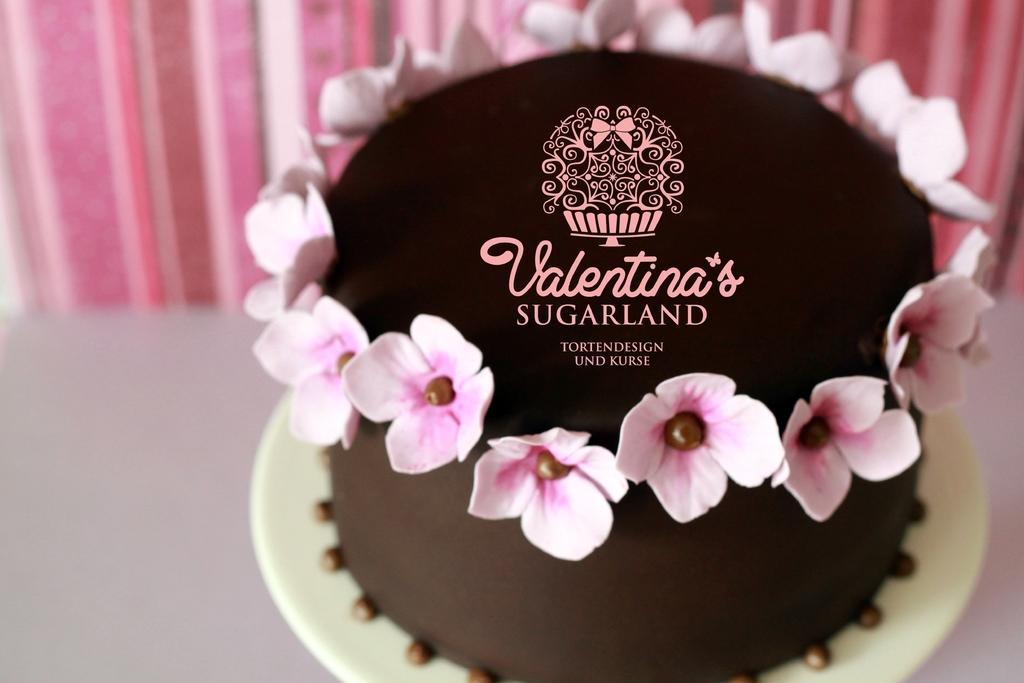Describe this image in one or two sentences. In this image we can see brown color cake, decorated with pink flowers. Background of the image, curtain is there. 